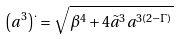<formula> <loc_0><loc_0><loc_500><loc_500>\left ( a ^ { 3 } \right ) ^ { . } = \sqrt { \beta ^ { 4 } + 4 \tilde { a } ^ { 3 } a ^ { 3 ( 2 - \Gamma ) } }</formula> 